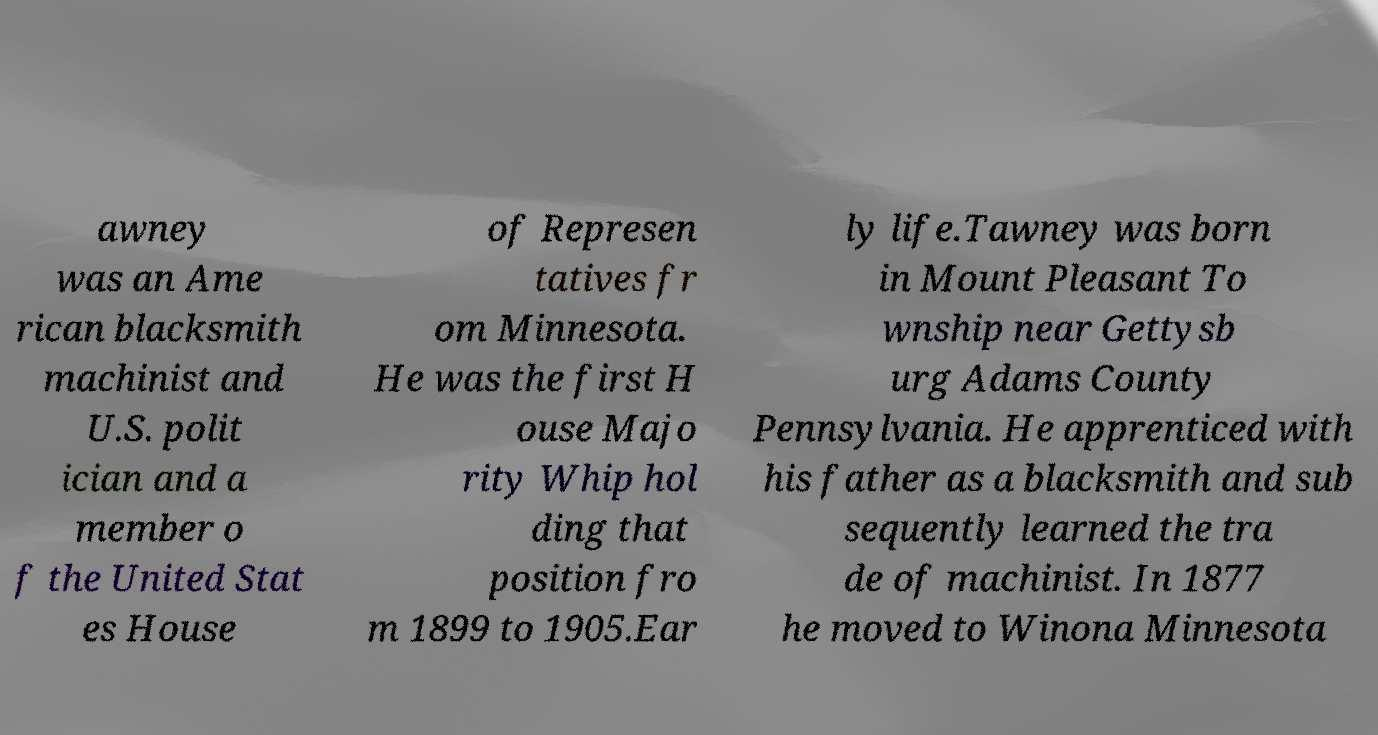Could you assist in decoding the text presented in this image and type it out clearly? awney was an Ame rican blacksmith machinist and U.S. polit ician and a member o f the United Stat es House of Represen tatives fr om Minnesota. He was the first H ouse Majo rity Whip hol ding that position fro m 1899 to 1905.Ear ly life.Tawney was born in Mount Pleasant To wnship near Gettysb urg Adams County Pennsylvania. He apprenticed with his father as a blacksmith and sub sequently learned the tra de of machinist. In 1877 he moved to Winona Minnesota 